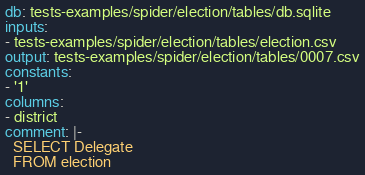<code> <loc_0><loc_0><loc_500><loc_500><_YAML_>db: tests-examples/spider/election/tables/db.sqlite
inputs:
- tests-examples/spider/election/tables/election.csv
output: tests-examples/spider/election/tables/0007.csv
constants:
- '1'
columns:
- district
comment: |-
  SELECT Delegate
  FROM election</code> 